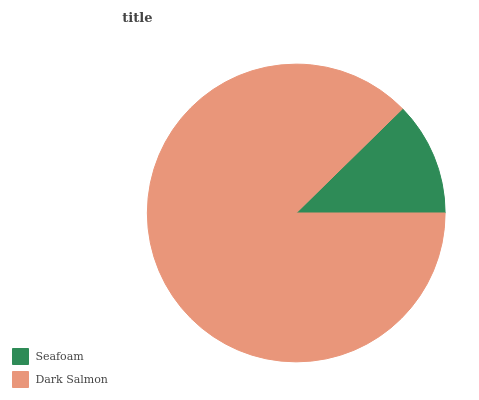Is Seafoam the minimum?
Answer yes or no. Yes. Is Dark Salmon the maximum?
Answer yes or no. Yes. Is Dark Salmon the minimum?
Answer yes or no. No. Is Dark Salmon greater than Seafoam?
Answer yes or no. Yes. Is Seafoam less than Dark Salmon?
Answer yes or no. Yes. Is Seafoam greater than Dark Salmon?
Answer yes or no. No. Is Dark Salmon less than Seafoam?
Answer yes or no. No. Is Dark Salmon the high median?
Answer yes or no. Yes. Is Seafoam the low median?
Answer yes or no. Yes. Is Seafoam the high median?
Answer yes or no. No. Is Dark Salmon the low median?
Answer yes or no. No. 